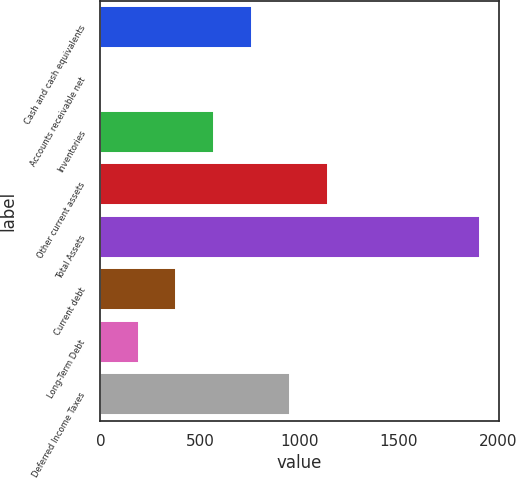Convert chart. <chart><loc_0><loc_0><loc_500><loc_500><bar_chart><fcel>Cash and cash equivalents<fcel>Accounts receivable net<fcel>Inventories<fcel>Other current assets<fcel>Total Assets<fcel>Current debt<fcel>Long-Term Debt<fcel>Deferred Income Taxes<nl><fcel>763.78<fcel>0.98<fcel>573.08<fcel>1145.18<fcel>1908<fcel>382.38<fcel>191.68<fcel>954.48<nl></chart> 